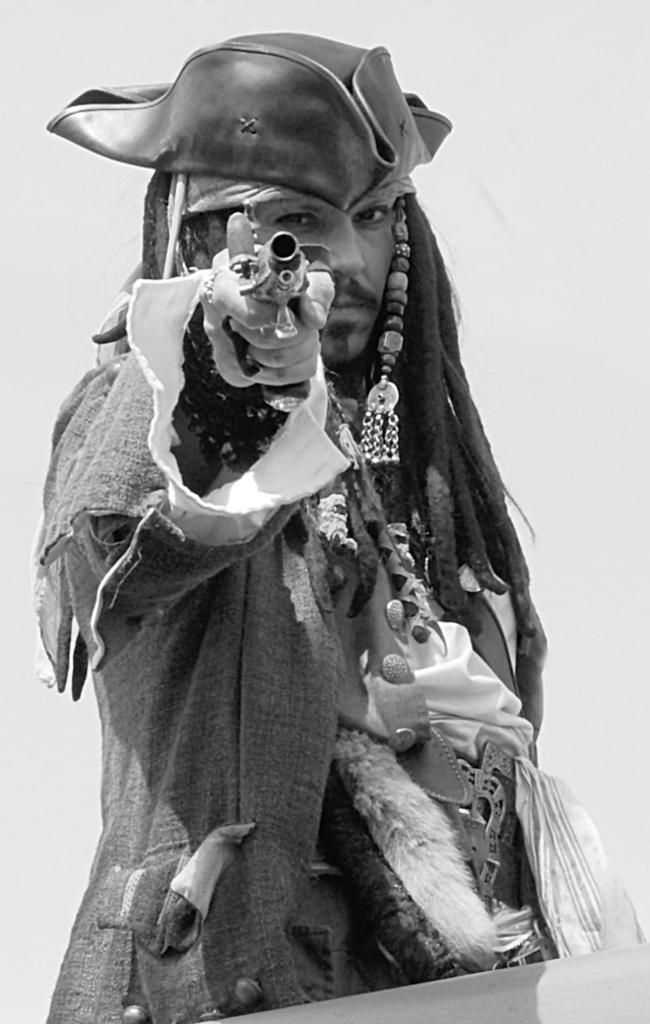What is the color scheme of the image? The image is black and white. Who or what is the main subject in the image? There is a person in the middle of the image. What is the person holding in the image? The person is holding a gun. What type of headwear is the person wearing? The person is wearing a cap. How does the person ensure the comfort of the passenger in the image? There is no passenger present in the image, as it only features a person holding a gun and wearing a cap. 